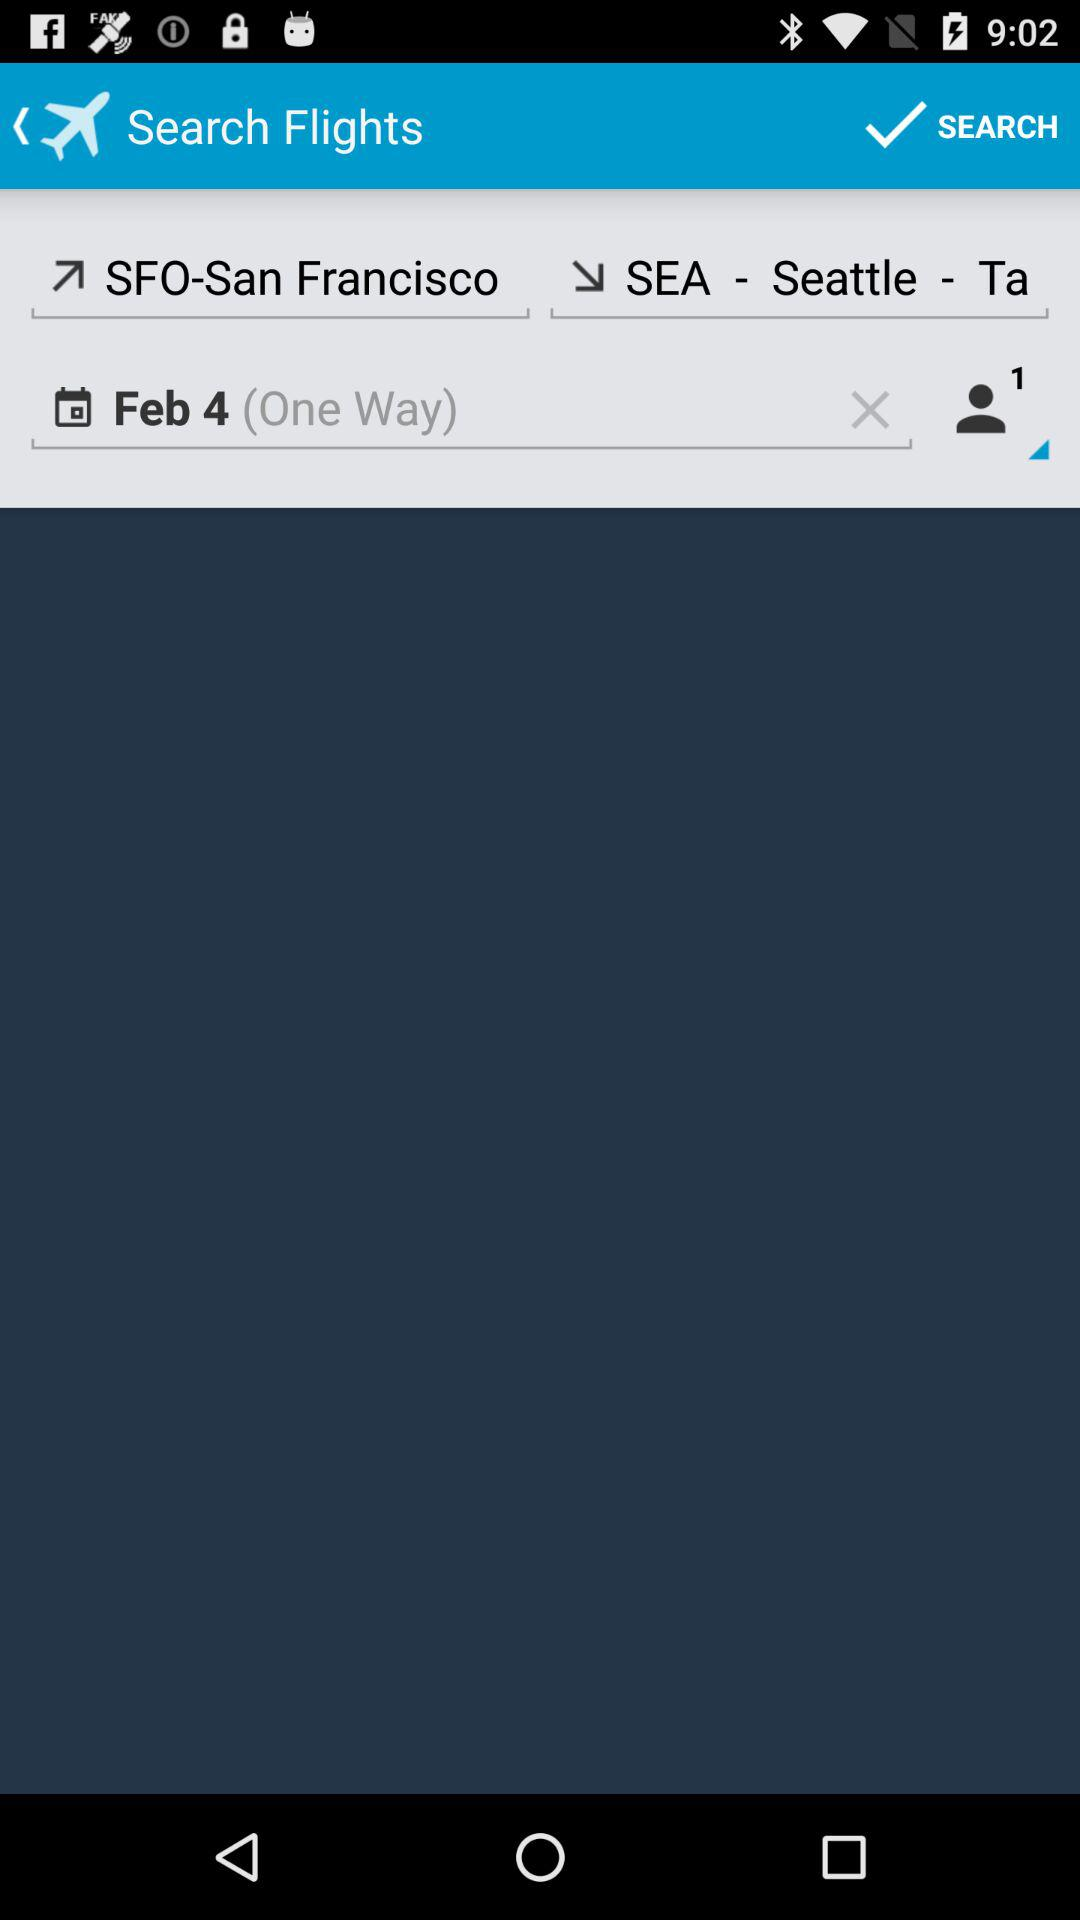What is the departure location? The departure location is SFO-San Francisco. 